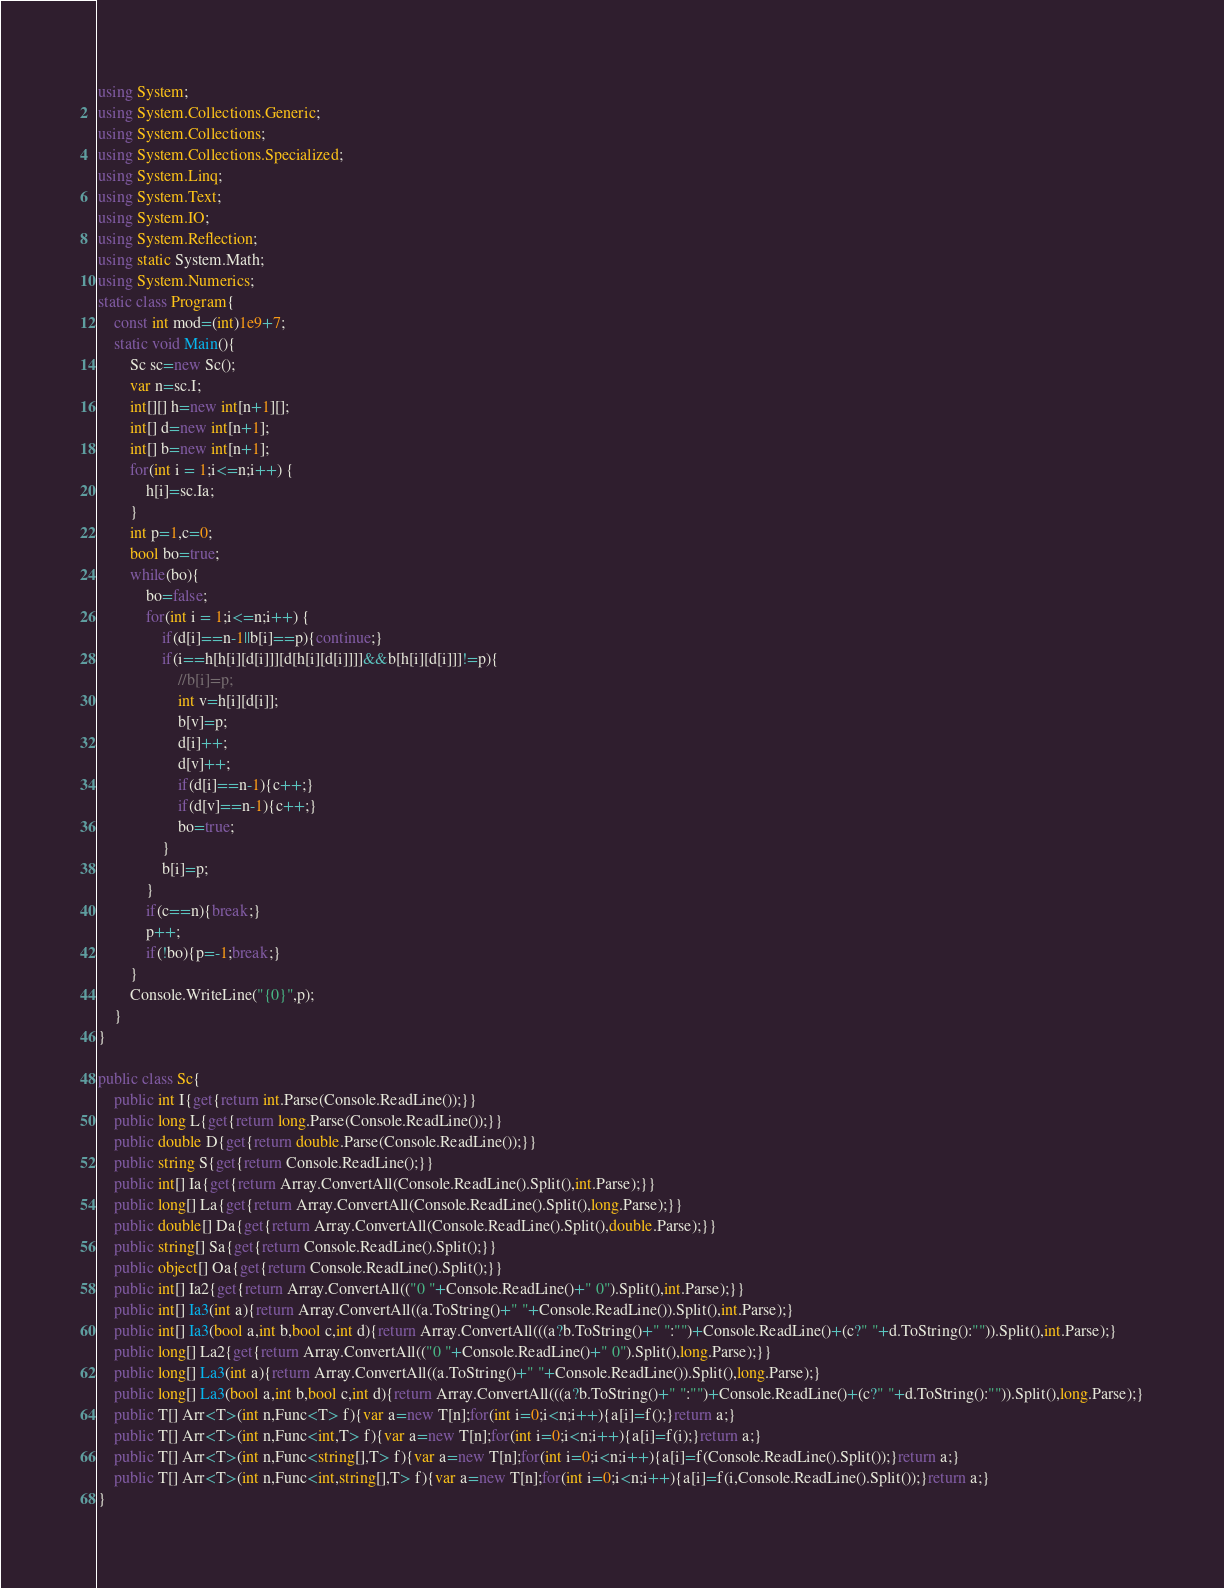Convert code to text. <code><loc_0><loc_0><loc_500><loc_500><_C#_>using System;
using System.Collections.Generic;
using System.Collections;
using System.Collections.Specialized;
using System.Linq;
using System.Text;
using System.IO;
using System.Reflection;
using static System.Math;
using System.Numerics;
static class Program{
	const int mod=(int)1e9+7;
	static void Main(){
		Sc sc=new Sc();
		var n=sc.I;
		int[][] h=new int[n+1][];
		int[] d=new int[n+1];
		int[] b=new int[n+1];
		for(int i = 1;i<=n;i++) {
			h[i]=sc.Ia;
		}
		int p=1,c=0;
		bool bo=true;
		while(bo){
			bo=false;
			for(int i = 1;i<=n;i++) {
				if(d[i]==n-1||b[i]==p){continue;}
				if(i==h[h[i][d[i]]][d[h[i][d[i]]]]&&b[h[i][d[i]]]!=p){
					//b[i]=p;
					int v=h[i][d[i]];
					b[v]=p;
					d[i]++;
					d[v]++;
					if(d[i]==n-1){c++;}
					if(d[v]==n-1){c++;}
					bo=true;
				}
				b[i]=p;
			}
			if(c==n){break;}
			p++;
			if(!bo){p=-1;break;}
		}
		Console.WriteLine("{0}",p);
	}
}

public class Sc{
	public int I{get{return int.Parse(Console.ReadLine());}}
	public long L{get{return long.Parse(Console.ReadLine());}}
	public double D{get{return double.Parse(Console.ReadLine());}}
	public string S{get{return Console.ReadLine();}}
	public int[] Ia{get{return Array.ConvertAll(Console.ReadLine().Split(),int.Parse);}}
	public long[] La{get{return Array.ConvertAll(Console.ReadLine().Split(),long.Parse);}}
	public double[] Da{get{return Array.ConvertAll(Console.ReadLine().Split(),double.Parse);}}
	public string[] Sa{get{return Console.ReadLine().Split();}}
	public object[] Oa{get{return Console.ReadLine().Split();}}
	public int[] Ia2{get{return Array.ConvertAll(("0 "+Console.ReadLine()+" 0").Split(),int.Parse);}}
	public int[] Ia3(int a){return Array.ConvertAll((a.ToString()+" "+Console.ReadLine()).Split(),int.Parse);}
	public int[] Ia3(bool a,int b,bool c,int d){return Array.ConvertAll(((a?b.ToString()+" ":"")+Console.ReadLine()+(c?" "+d.ToString():"")).Split(),int.Parse);}
	public long[] La2{get{return Array.ConvertAll(("0 "+Console.ReadLine()+" 0").Split(),long.Parse);}}
	public long[] La3(int a){return Array.ConvertAll((a.ToString()+" "+Console.ReadLine()).Split(),long.Parse);}
	public long[] La3(bool a,int b,bool c,int d){return Array.ConvertAll(((a?b.ToString()+" ":"")+Console.ReadLine()+(c?" "+d.ToString():"")).Split(),long.Parse);}
	public T[] Arr<T>(int n,Func<T> f){var a=new T[n];for(int i=0;i<n;i++){a[i]=f();}return a;}
	public T[] Arr<T>(int n,Func<int,T> f){var a=new T[n];for(int i=0;i<n;i++){a[i]=f(i);}return a;}
	public T[] Arr<T>(int n,Func<string[],T> f){var a=new T[n];for(int i=0;i<n;i++){a[i]=f(Console.ReadLine().Split());}return a;}
	public T[] Arr<T>(int n,Func<int,string[],T> f){var a=new T[n];for(int i=0;i<n;i++){a[i]=f(i,Console.ReadLine().Split());}return a;}
}</code> 